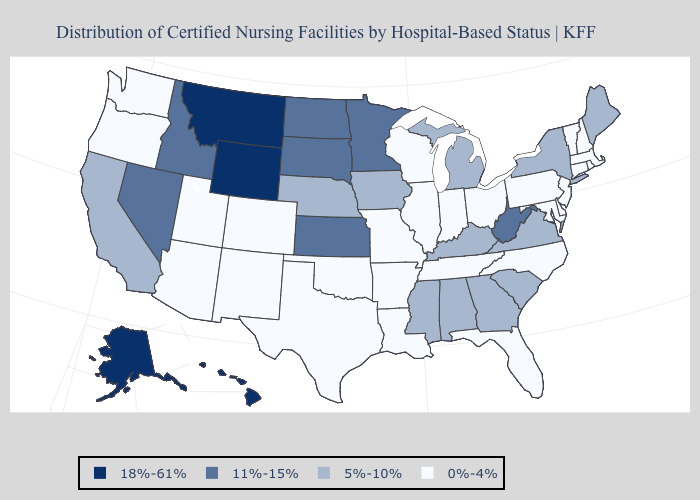Does Kentucky have the same value as Georgia?
Concise answer only. Yes. What is the lowest value in the USA?
Give a very brief answer. 0%-4%. What is the lowest value in the USA?
Concise answer only. 0%-4%. What is the highest value in the USA?
Short answer required. 18%-61%. What is the lowest value in the MidWest?
Write a very short answer. 0%-4%. Name the states that have a value in the range 18%-61%?
Keep it brief. Alaska, Hawaii, Montana, Wyoming. Name the states that have a value in the range 18%-61%?
Give a very brief answer. Alaska, Hawaii, Montana, Wyoming. What is the highest value in the USA?
Answer briefly. 18%-61%. What is the value of California?
Keep it brief. 5%-10%. Does New York have the highest value in the Northeast?
Give a very brief answer. Yes. What is the value of Arizona?
Write a very short answer. 0%-4%. Among the states that border Washington , which have the lowest value?
Be succinct. Oregon. Which states have the lowest value in the MidWest?
Give a very brief answer. Illinois, Indiana, Missouri, Ohio, Wisconsin. What is the value of Massachusetts?
Concise answer only. 0%-4%. Does the map have missing data?
Concise answer only. No. 